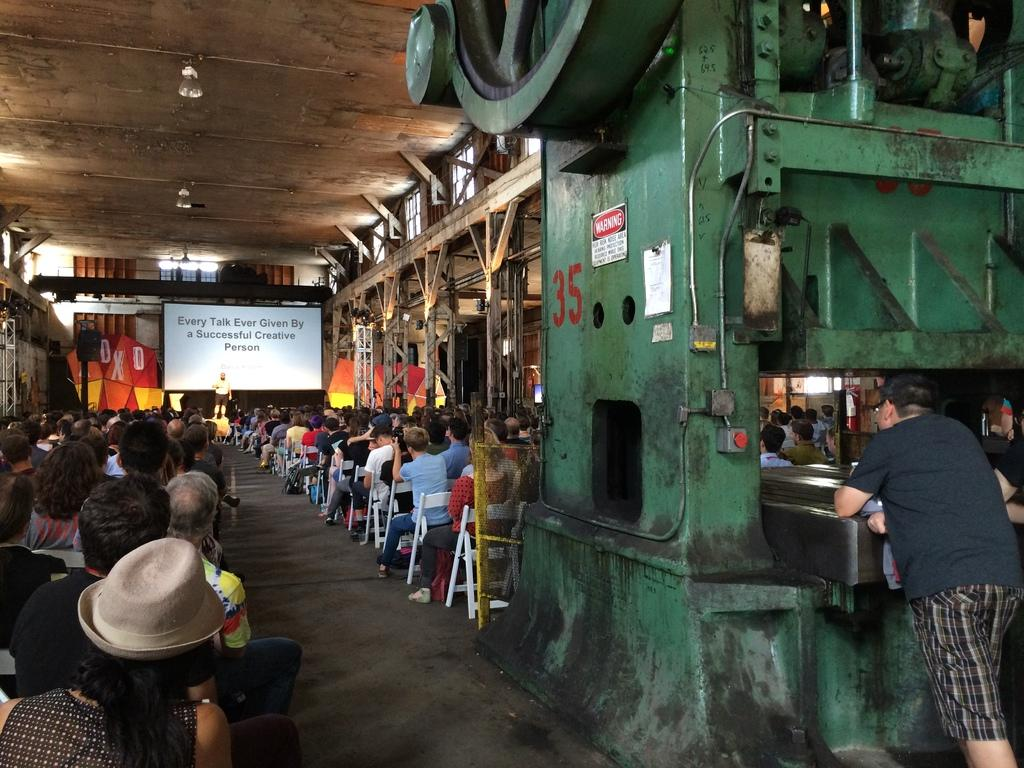What is the main object in the image? There is a screen in the image. What else can be seen in the image besides the screen? There is a banner, a machine, posters, a group of people sitting on chairs, a person standing on the floor, lights, and poles in the image. Can you describe the group of people in the image? There is a group of people sitting on chairs in the image. What is the person standing on the floor doing? The person standing on the floor is not specified in the image. What type of lunch is being served to the nation in the image? There is no lunch or nation mentioned in the image; it features a screen, banner, machine, posters, group of people, person standing, lights, and poles. 